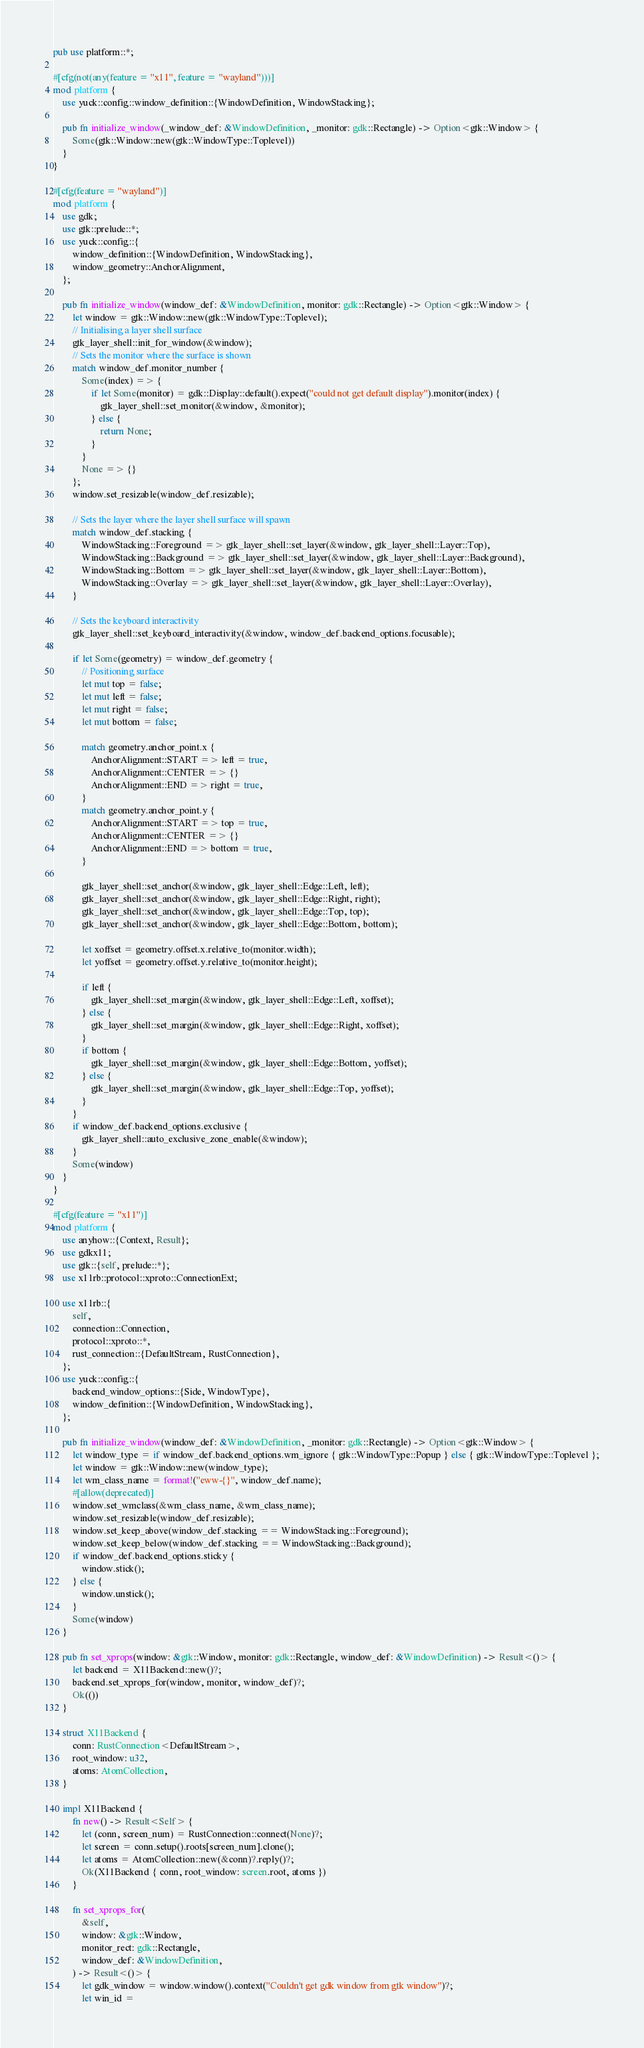<code> <loc_0><loc_0><loc_500><loc_500><_Rust_>pub use platform::*;

#[cfg(not(any(feature = "x11", feature = "wayland")))]
mod platform {
    use yuck::config::window_definition::{WindowDefinition, WindowStacking};

    pub fn initialize_window(_window_def: &WindowDefinition, _monitor: gdk::Rectangle) -> Option<gtk::Window> {
        Some(gtk::Window::new(gtk::WindowType::Toplevel))
    }
}

#[cfg(feature = "wayland")]
mod platform {
    use gdk;
    use gtk::prelude::*;
    use yuck::config::{
        window_definition::{WindowDefinition, WindowStacking},
        window_geometry::AnchorAlignment,
    };

    pub fn initialize_window(window_def: &WindowDefinition, monitor: gdk::Rectangle) -> Option<gtk::Window> {
        let window = gtk::Window::new(gtk::WindowType::Toplevel);
        // Initialising a layer shell surface
        gtk_layer_shell::init_for_window(&window);
        // Sets the monitor where the surface is shown
        match window_def.monitor_number {
            Some(index) => {
                if let Some(monitor) = gdk::Display::default().expect("could not get default display").monitor(index) {
                    gtk_layer_shell::set_monitor(&window, &monitor);
                } else {
                    return None;
                }
            }
            None => {}
        };
        window.set_resizable(window_def.resizable);

        // Sets the layer where the layer shell surface will spawn
        match window_def.stacking {
            WindowStacking::Foreground => gtk_layer_shell::set_layer(&window, gtk_layer_shell::Layer::Top),
            WindowStacking::Background => gtk_layer_shell::set_layer(&window, gtk_layer_shell::Layer::Background),
            WindowStacking::Bottom => gtk_layer_shell::set_layer(&window, gtk_layer_shell::Layer::Bottom),
            WindowStacking::Overlay => gtk_layer_shell::set_layer(&window, gtk_layer_shell::Layer::Overlay),
        }

        // Sets the keyboard interactivity
        gtk_layer_shell::set_keyboard_interactivity(&window, window_def.backend_options.focusable);

        if let Some(geometry) = window_def.geometry {
            // Positioning surface
            let mut top = false;
            let mut left = false;
            let mut right = false;
            let mut bottom = false;

            match geometry.anchor_point.x {
                AnchorAlignment::START => left = true,
                AnchorAlignment::CENTER => {}
                AnchorAlignment::END => right = true,
            }
            match geometry.anchor_point.y {
                AnchorAlignment::START => top = true,
                AnchorAlignment::CENTER => {}
                AnchorAlignment::END => bottom = true,
            }

            gtk_layer_shell::set_anchor(&window, gtk_layer_shell::Edge::Left, left);
            gtk_layer_shell::set_anchor(&window, gtk_layer_shell::Edge::Right, right);
            gtk_layer_shell::set_anchor(&window, gtk_layer_shell::Edge::Top, top);
            gtk_layer_shell::set_anchor(&window, gtk_layer_shell::Edge::Bottom, bottom);

            let xoffset = geometry.offset.x.relative_to(monitor.width);
            let yoffset = geometry.offset.y.relative_to(monitor.height);

            if left {
                gtk_layer_shell::set_margin(&window, gtk_layer_shell::Edge::Left, xoffset);
            } else {
                gtk_layer_shell::set_margin(&window, gtk_layer_shell::Edge::Right, xoffset);
            }
            if bottom {
                gtk_layer_shell::set_margin(&window, gtk_layer_shell::Edge::Bottom, yoffset);
            } else {
                gtk_layer_shell::set_margin(&window, gtk_layer_shell::Edge::Top, yoffset);
            }
        }
        if window_def.backend_options.exclusive {
            gtk_layer_shell::auto_exclusive_zone_enable(&window);
        }
        Some(window)
    }
}

#[cfg(feature = "x11")]
mod platform {
    use anyhow::{Context, Result};
    use gdkx11;
    use gtk::{self, prelude::*};
    use x11rb::protocol::xproto::ConnectionExt;

    use x11rb::{
        self,
        connection::Connection,
        protocol::xproto::*,
        rust_connection::{DefaultStream, RustConnection},
    };
    use yuck::config::{
        backend_window_options::{Side, WindowType},
        window_definition::{WindowDefinition, WindowStacking},
    };

    pub fn initialize_window(window_def: &WindowDefinition, _monitor: gdk::Rectangle) -> Option<gtk::Window> {
        let window_type = if window_def.backend_options.wm_ignore { gtk::WindowType::Popup } else { gtk::WindowType::Toplevel };
        let window = gtk::Window::new(window_type);
        let wm_class_name = format!("eww-{}", window_def.name);
        #[allow(deprecated)]
        window.set_wmclass(&wm_class_name, &wm_class_name);
        window.set_resizable(window_def.resizable);
        window.set_keep_above(window_def.stacking == WindowStacking::Foreground);
        window.set_keep_below(window_def.stacking == WindowStacking::Background);
        if window_def.backend_options.sticky {
            window.stick();
        } else {
            window.unstick();
        }
        Some(window)
    }

    pub fn set_xprops(window: &gtk::Window, monitor: gdk::Rectangle, window_def: &WindowDefinition) -> Result<()> {
        let backend = X11Backend::new()?;
        backend.set_xprops_for(window, monitor, window_def)?;
        Ok(())
    }

    struct X11Backend {
        conn: RustConnection<DefaultStream>,
        root_window: u32,
        atoms: AtomCollection,
    }

    impl X11Backend {
        fn new() -> Result<Self> {
            let (conn, screen_num) = RustConnection::connect(None)?;
            let screen = conn.setup().roots[screen_num].clone();
            let atoms = AtomCollection::new(&conn)?.reply()?;
            Ok(X11Backend { conn, root_window: screen.root, atoms })
        }

        fn set_xprops_for(
            &self,
            window: &gtk::Window,
            monitor_rect: gdk::Rectangle,
            window_def: &WindowDefinition,
        ) -> Result<()> {
            let gdk_window = window.window().context("Couldn't get gdk window from gtk window")?;
            let win_id =</code> 